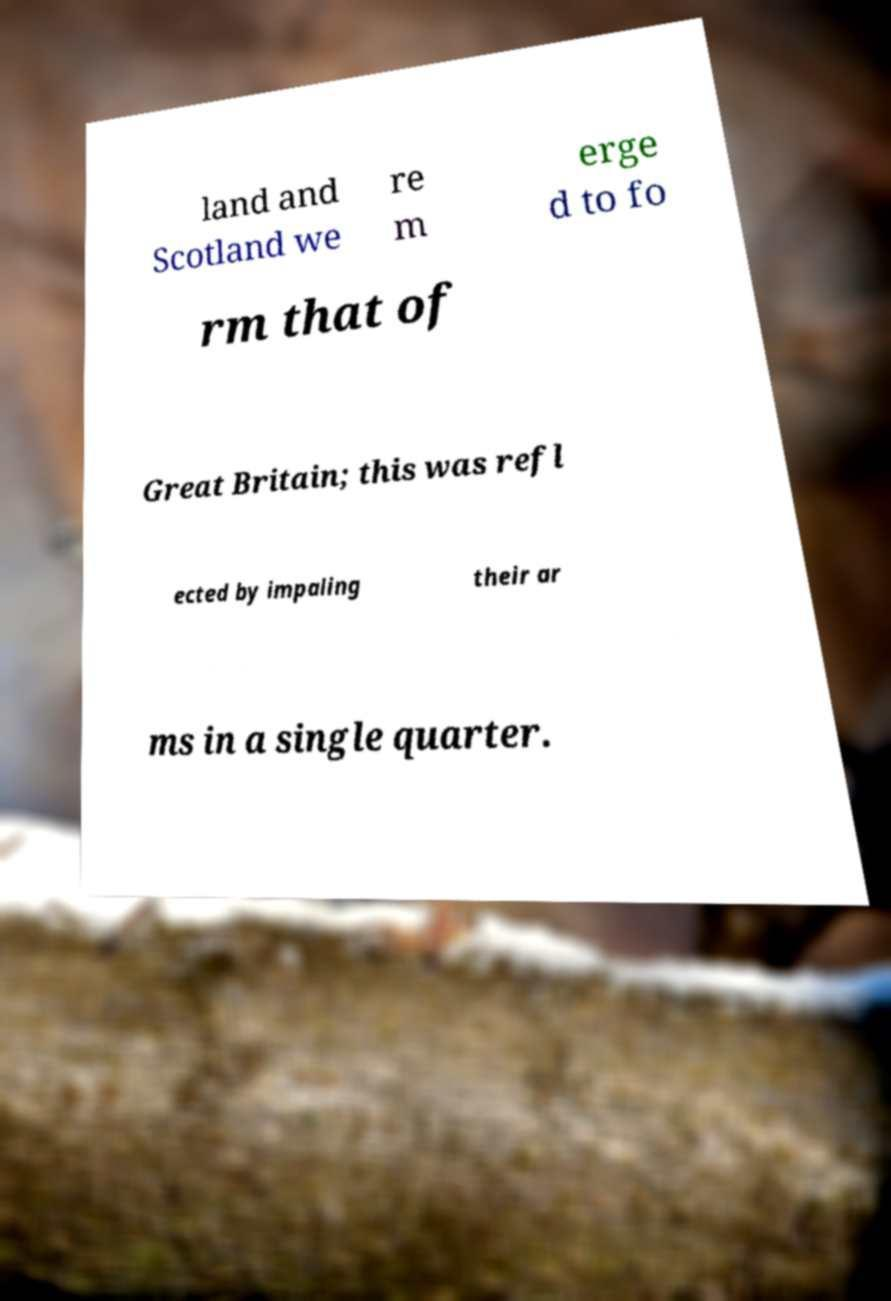Please identify and transcribe the text found in this image. land and Scotland we re m erge d to fo rm that of Great Britain; this was refl ected by impaling their ar ms in a single quarter. 